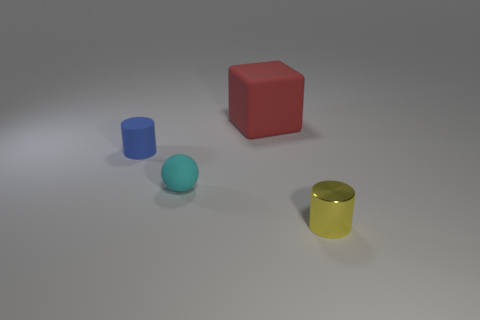Are there any other things that have the same material as the small yellow cylinder?
Give a very brief answer. No. Are there more small blue objects in front of the rubber block than small blue cylinders on the right side of the tiny yellow metal thing?
Your answer should be compact. Yes. There is a cyan sphere that is the same size as the yellow cylinder; what is its material?
Provide a succinct answer. Rubber. How many things are either purple spheres or blue rubber cylinders that are in front of the red rubber object?
Your answer should be very brief. 1. There is a matte cylinder; does it have the same size as the cylinder in front of the small blue rubber object?
Make the answer very short. Yes. What number of cubes are blue matte objects or cyan matte things?
Your answer should be very brief. 0. What number of things are in front of the red matte block and right of the tiny blue cylinder?
Offer a very short reply. 2. What shape is the small object that is to the right of the red block?
Give a very brief answer. Cylinder. Is the red object made of the same material as the cyan thing?
Keep it short and to the point. Yes. Is there anything else that is the same size as the red object?
Your response must be concise. No. 